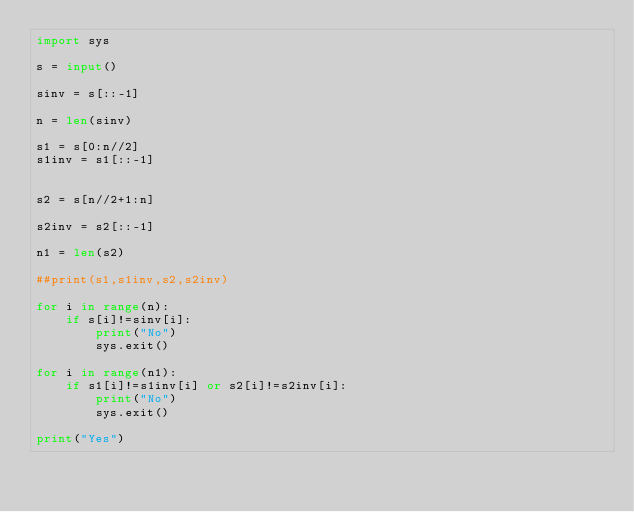<code> <loc_0><loc_0><loc_500><loc_500><_Python_>import sys

s = input()

sinv = s[::-1]

n = len(sinv)

s1 = s[0:n//2]
s1inv = s1[::-1]


s2 = s[n//2+1:n]

s2inv = s2[::-1]

n1 = len(s2)

##print(s1,s1inv,s2,s2inv)

for i in range(n):
    if s[i]!=sinv[i]:
        print("No")
        sys.exit()

for i in range(n1):
    if s1[i]!=s1inv[i] or s2[i]!=s2inv[i]:
        print("No")
        sys.exit()

print("Yes")
</code> 